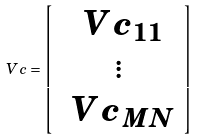Convert formula to latex. <formula><loc_0><loc_0><loc_500><loc_500>\ V { c } = \left [ \begin{array} { c } \ V { c } _ { 1 1 } \\ \vdots \\ \ V { c } _ { M N } \\ \end{array} \right ]</formula> 